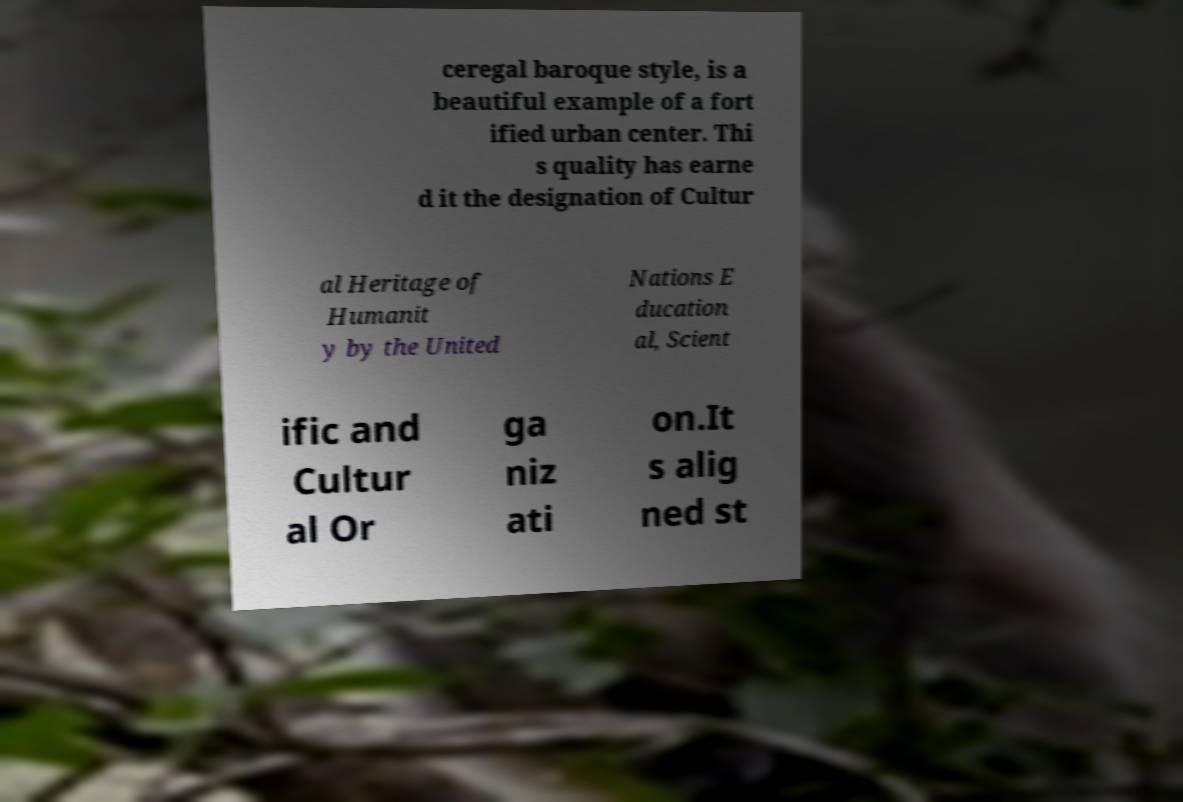I need the written content from this picture converted into text. Can you do that? ceregal baroque style, is a beautiful example of a fort ified urban center. Thi s quality has earne d it the designation of Cultur al Heritage of Humanit y by the United Nations E ducation al, Scient ific and Cultur al Or ga niz ati on.It s alig ned st 